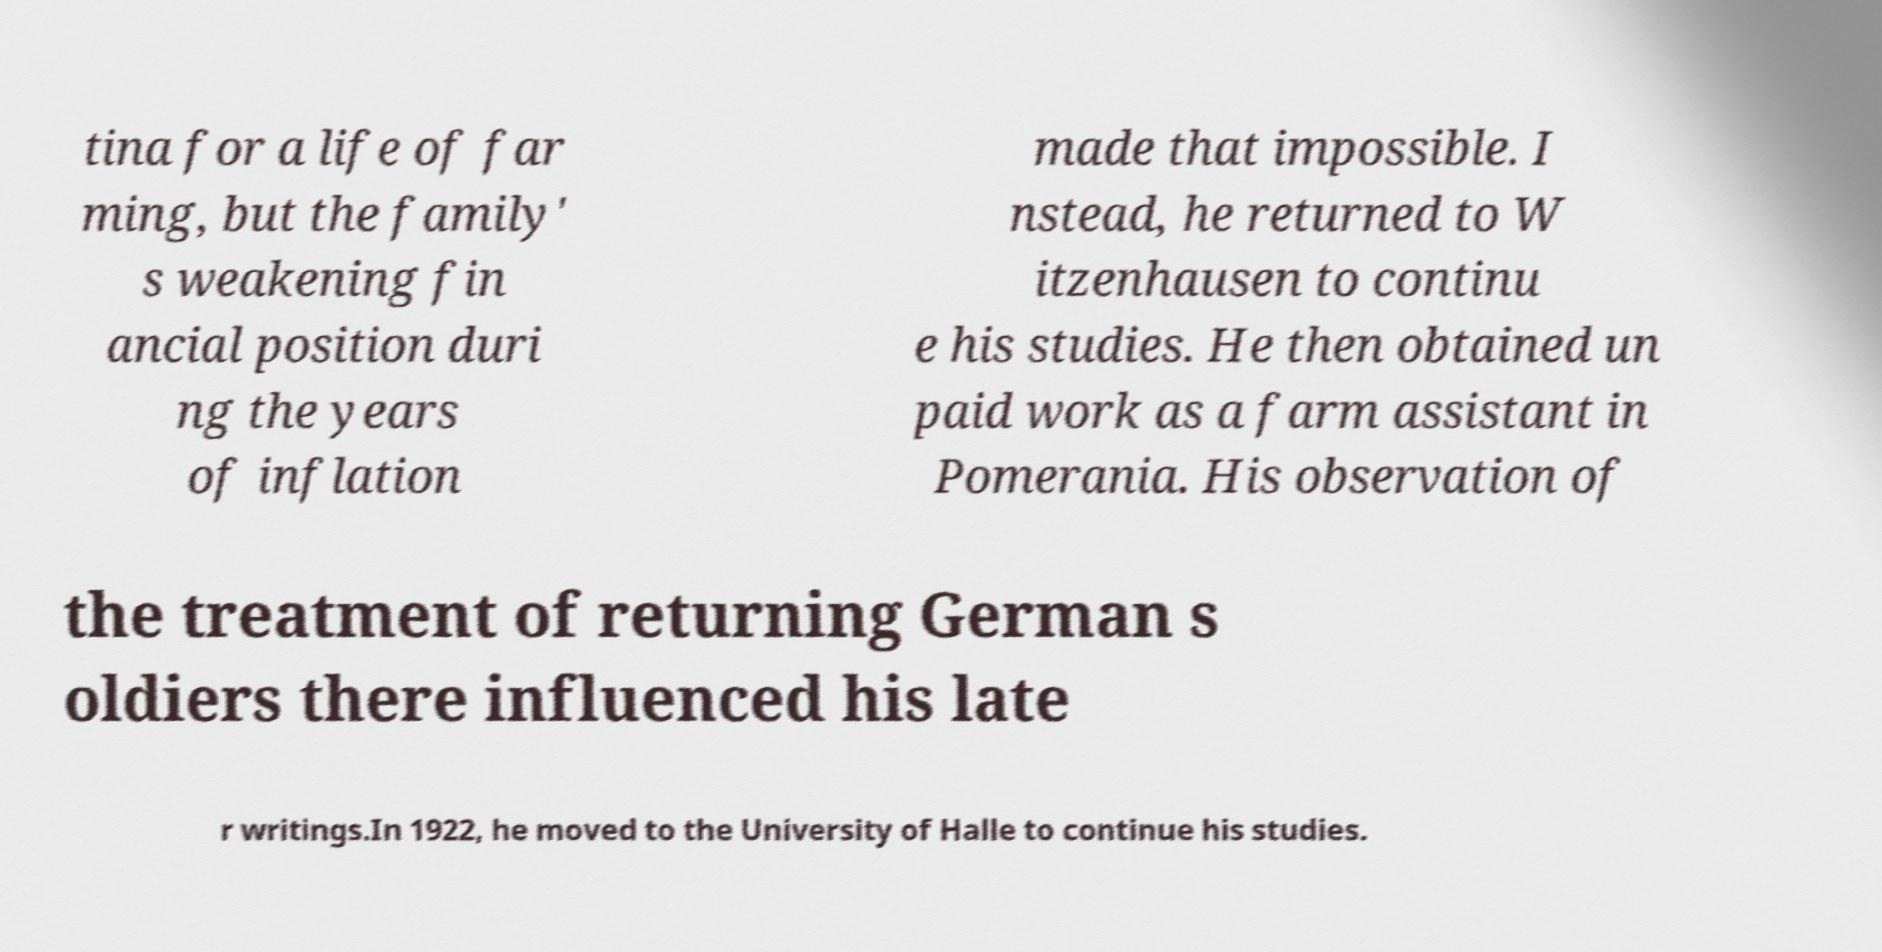Can you read and provide the text displayed in the image?This photo seems to have some interesting text. Can you extract and type it out for me? tina for a life of far ming, but the family' s weakening fin ancial position duri ng the years of inflation made that impossible. I nstead, he returned to W itzenhausen to continu e his studies. He then obtained un paid work as a farm assistant in Pomerania. His observation of the treatment of returning German s oldiers there influenced his late r writings.In 1922, he moved to the University of Halle to continue his studies. 